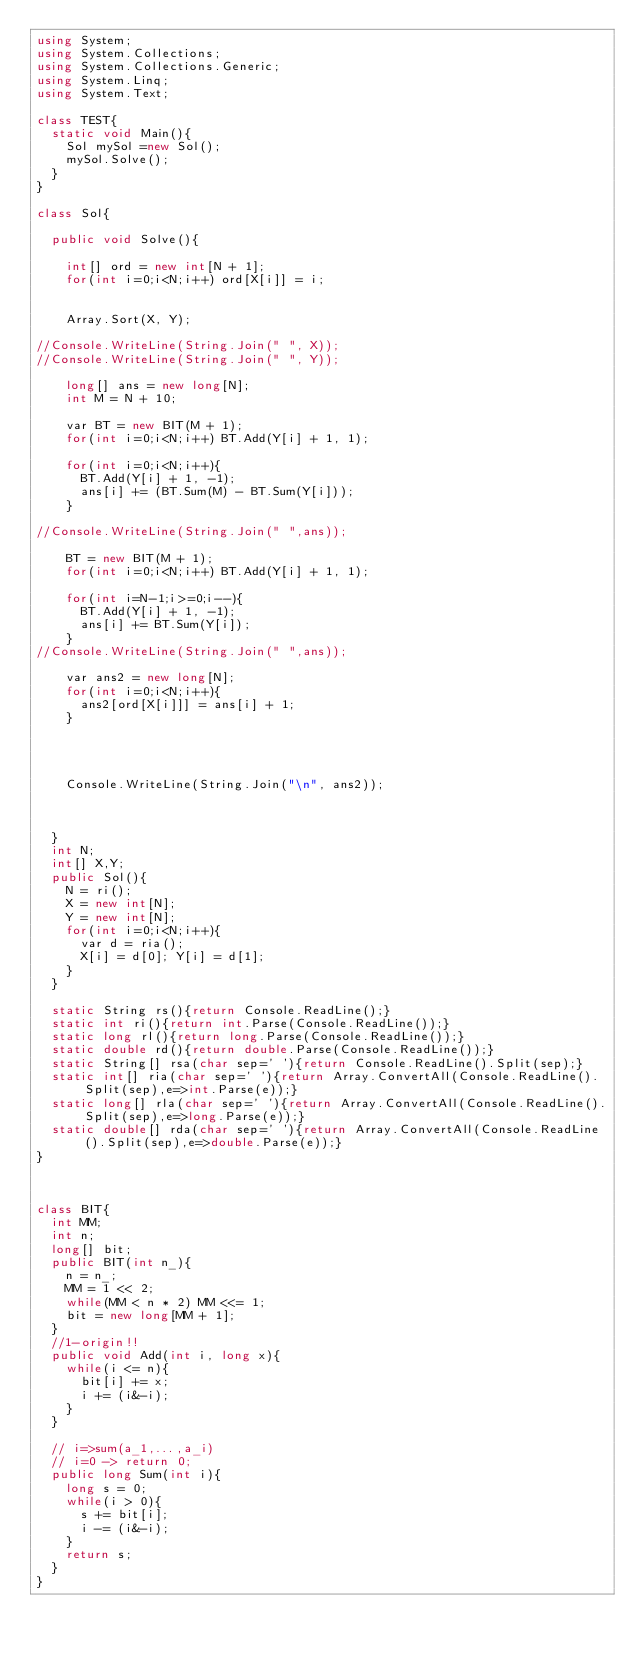Convert code to text. <code><loc_0><loc_0><loc_500><loc_500><_C#_>using System;
using System.Collections;
using System.Collections.Generic;
using System.Linq;
using System.Text;

class TEST{
	static void Main(){
		Sol mySol =new Sol();
		mySol.Solve();
	}
}

class Sol{
	
	public void Solve(){
		
		int[] ord = new int[N + 1];
		for(int i=0;i<N;i++) ord[X[i]] = i;
		
		
		Array.Sort(X, Y);
		
//Console.WriteLine(String.Join(" ", X));
//Console.WriteLine(String.Join(" ", Y));
		
		long[] ans = new long[N];
		int M = N + 10;
		
		var BT = new BIT(M + 1);
		for(int i=0;i<N;i++) BT.Add(Y[i] + 1, 1);
		
		for(int i=0;i<N;i++){
			BT.Add(Y[i] + 1, -1);
			ans[i] += (BT.Sum(M) - BT.Sum(Y[i]));
		}
		
//Console.WriteLine(String.Join(" ",ans));
		
		BT = new BIT(M + 1);
		for(int i=0;i<N;i++) BT.Add(Y[i] + 1, 1);
		
		for(int i=N-1;i>=0;i--){
			BT.Add(Y[i] + 1, -1);
			ans[i] += BT.Sum(Y[i]);
		}
//Console.WriteLine(String.Join(" ",ans));
		
		var ans2 = new long[N];
		for(int i=0;i<N;i++){
			ans2[ord[X[i]]] = ans[i] + 1;
		}
		
		
		
		
		Console.WriteLine(String.Join("\n", ans2));
		
		
		
	}
	int N;
	int[] X,Y;
	public Sol(){
		N = ri();
		X = new int[N];
		Y = new int[N];
		for(int i=0;i<N;i++){
			var d = ria();
			X[i] = d[0]; Y[i] = d[1];
		}
	}

	static String rs(){return Console.ReadLine();}
	static int ri(){return int.Parse(Console.ReadLine());}
	static long rl(){return long.Parse(Console.ReadLine());}
	static double rd(){return double.Parse(Console.ReadLine());}
	static String[] rsa(char sep=' '){return Console.ReadLine().Split(sep);}
	static int[] ria(char sep=' '){return Array.ConvertAll(Console.ReadLine().Split(sep),e=>int.Parse(e));}
	static long[] rla(char sep=' '){return Array.ConvertAll(Console.ReadLine().Split(sep),e=>long.Parse(e));}
	static double[] rda(char sep=' '){return Array.ConvertAll(Console.ReadLine().Split(sep),e=>double.Parse(e));}
}



class BIT{
	int MM;
	int n;
	long[] bit;
	public BIT(int n_){
		n = n_;
		MM = 1 << 2;
		while(MM < n * 2) MM <<= 1;
		bit = new long[MM + 1];
	}
	//1-origin!!
	public void Add(int i, long x){
		while(i <= n){
			bit[i] += x;
			i += (i&-i);
		}
	}
	
	// i=>sum(a_1,...,a_i)
	// i=0 -> return 0;
	public long Sum(int i){
		long s = 0;
		while(i > 0){
			s += bit[i];
			i -= (i&-i);
		}
		return s;
	}
}

</code> 